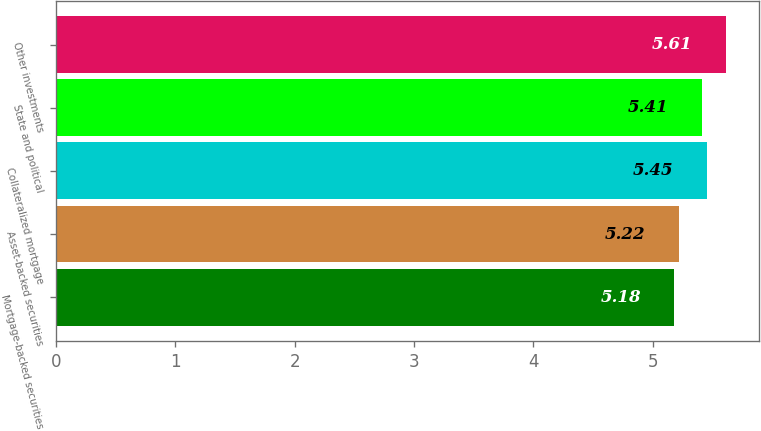Convert chart. <chart><loc_0><loc_0><loc_500><loc_500><bar_chart><fcel>Mortgage-backed securities<fcel>Asset-backed securities<fcel>Collateralized mortgage<fcel>State and political<fcel>Other investments<nl><fcel>5.18<fcel>5.22<fcel>5.45<fcel>5.41<fcel>5.61<nl></chart> 